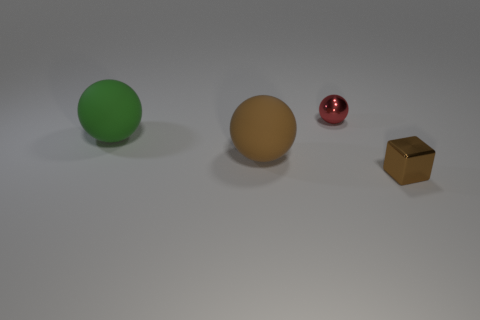Subtract all big brown spheres. How many spheres are left? 2 Add 3 shiny cubes. How many objects exist? 7 Subtract all cubes. How many objects are left? 3 Subtract all green balls. How many balls are left? 2 Subtract 2 spheres. How many spheres are left? 1 Subtract all small brown metallic things. Subtract all balls. How many objects are left? 0 Add 2 brown matte spheres. How many brown matte spheres are left? 3 Add 2 small purple shiny objects. How many small purple shiny objects exist? 2 Subtract 0 yellow balls. How many objects are left? 4 Subtract all purple cubes. Subtract all yellow cylinders. How many cubes are left? 1 